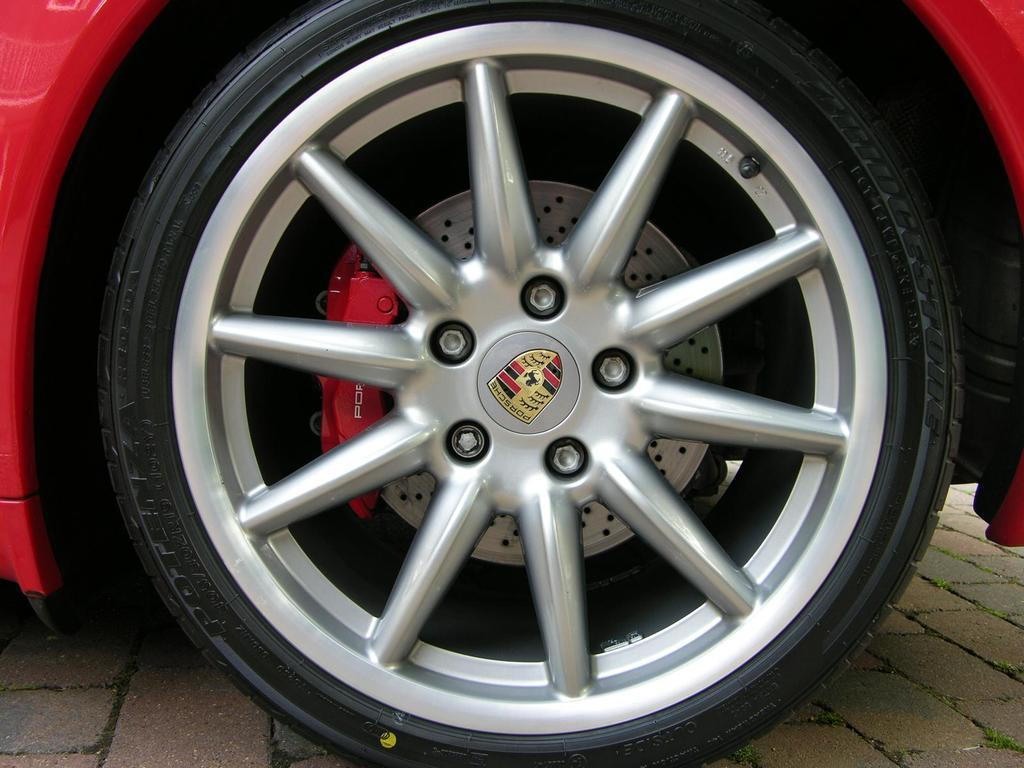What color is the car in the image? The car in the image is red. What are the car's wheels called? The car has tires. What is on the car that represents its brand or company? The car has a logo. What type of surface can be seen in the image? There is a path visible in the image. What type of vegetation is present in the image? There is green grass in the image. What type of air can be seen coming out of the car's exhaust in the image? There is no visible exhaust in the image, so it is not possible to determine the type of air coming out. 